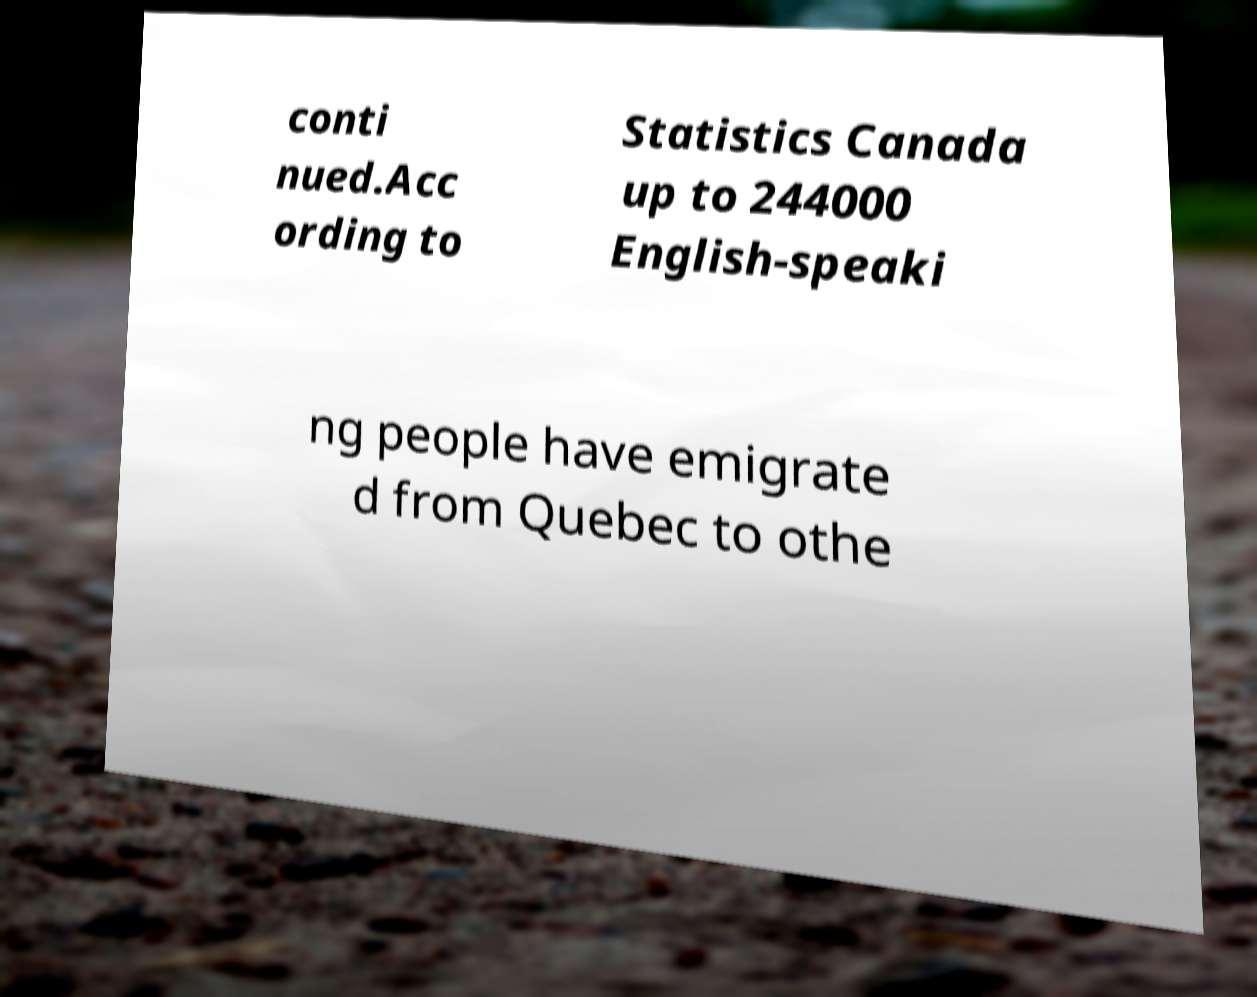Could you extract and type out the text from this image? conti nued.Acc ording to Statistics Canada up to 244000 English-speaki ng people have emigrate d from Quebec to othe 